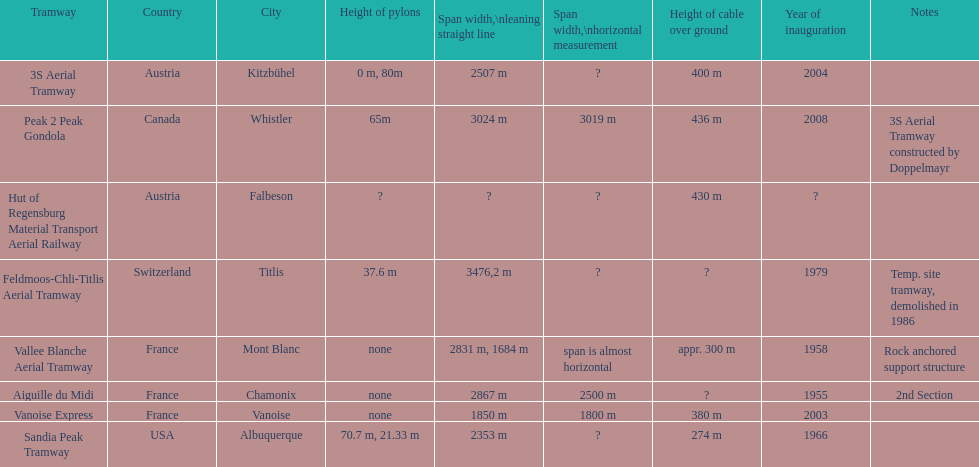Was the sandia peak tramway innagurate before or after the 3s aerial tramway? Before. 